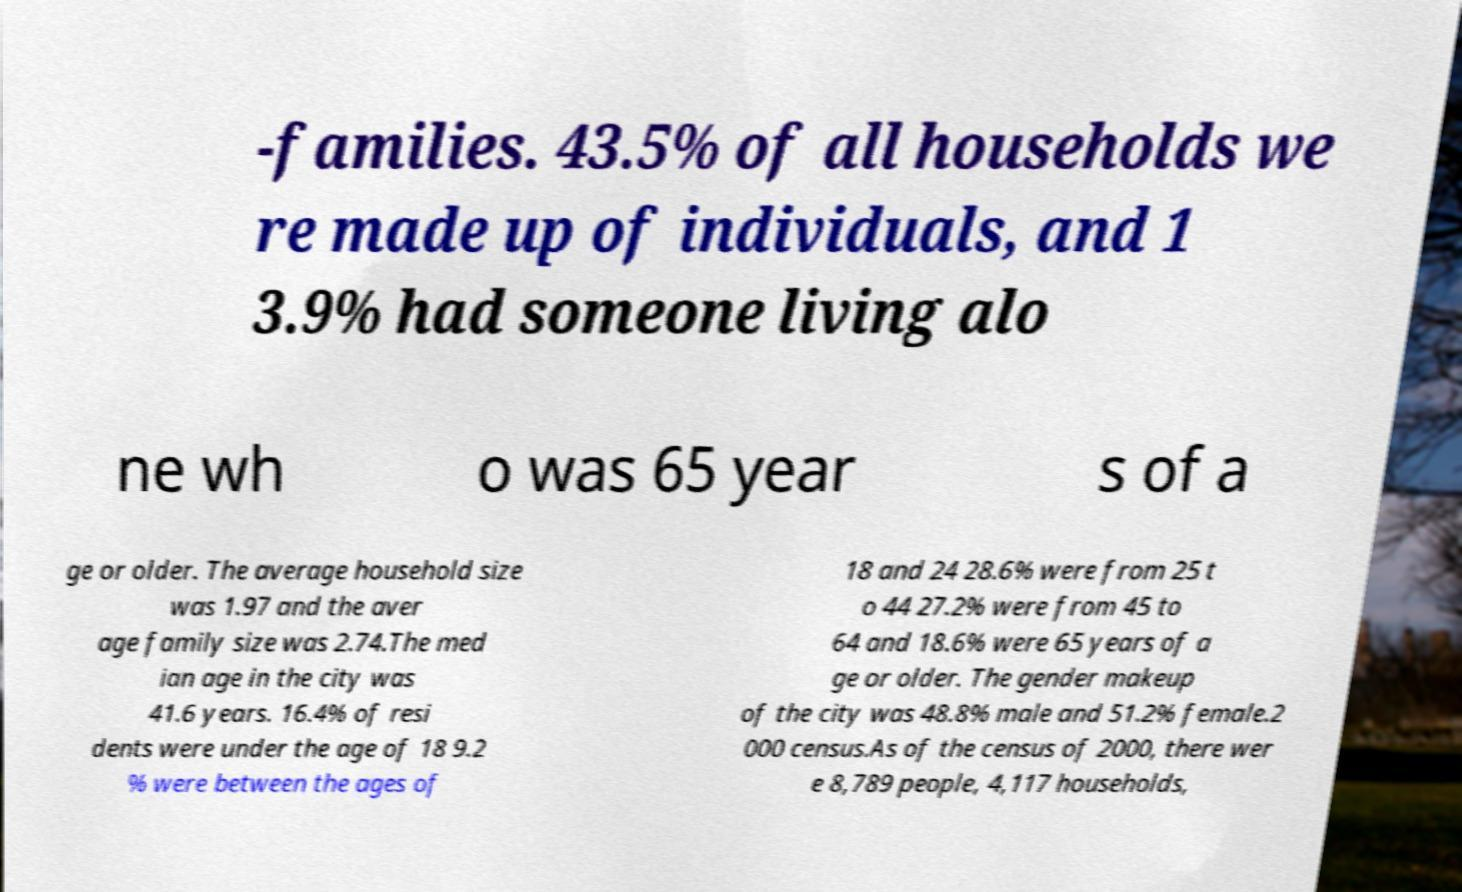For documentation purposes, I need the text within this image transcribed. Could you provide that? -families. 43.5% of all households we re made up of individuals, and 1 3.9% had someone living alo ne wh o was 65 year s of a ge or older. The average household size was 1.97 and the aver age family size was 2.74.The med ian age in the city was 41.6 years. 16.4% of resi dents were under the age of 18 9.2 % were between the ages of 18 and 24 28.6% were from 25 t o 44 27.2% were from 45 to 64 and 18.6% were 65 years of a ge or older. The gender makeup of the city was 48.8% male and 51.2% female.2 000 census.As of the census of 2000, there wer e 8,789 people, 4,117 households, 